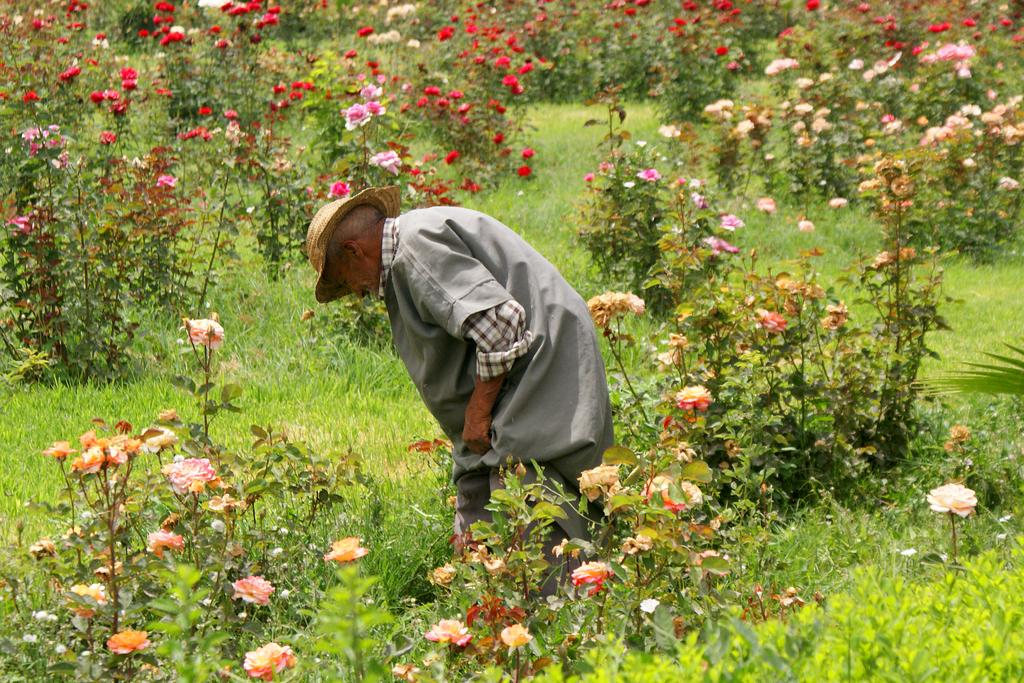Who or what is the main subject in the center of the picture? There is a person in the center of the picture. What type of vegetation can be seen in the image? There are plants, roses, and grass in the image. What type of powder is being used to make the roses cream-colored in the image? There is no indication in the image that any powder or cream is being used on the roses; they appear to be their natural color. 